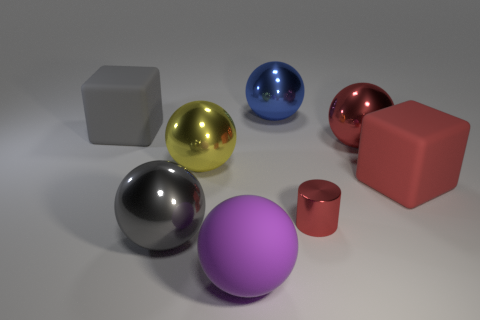Is there any other thing that has the same size as the metallic cylinder?
Your answer should be compact. No. What number of other objects are the same shape as the large red rubber thing?
Keep it short and to the point. 1. Do the big rubber thing that is behind the large yellow shiny thing and the large yellow shiny object left of the purple object have the same shape?
Make the answer very short. No. What number of cubes are either gray objects or big objects?
Provide a short and direct response. 2. What material is the big red object that is in front of the large yellow object left of the large rubber thing in front of the tiny red cylinder?
Provide a short and direct response. Rubber. How many other objects are there of the same size as the gray cube?
Provide a short and direct response. 6. The other metallic thing that is the same color as the small object is what size?
Offer a terse response. Large. Are there more big rubber cubes that are right of the purple thing than blue balls?
Offer a terse response. No. Is there a ball that has the same color as the tiny cylinder?
Ensure brevity in your answer.  Yes. The rubber ball that is the same size as the yellow metal object is what color?
Offer a very short reply. Purple. 